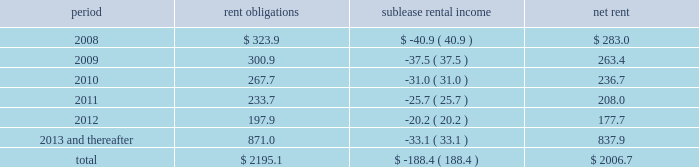Future minimum lease commitments for office premises and equipment under non-cancelable leases , along with minimum sublease rental income to be received under non-cancelable subleases , are as follows : period rent obligations sublease rental income net rent .
Guarantees we have certain contingent obligations under guarantees of certain of our subsidiaries ( 201cparent company guarantees 201d ) relating principally to credit facilities , guarantees of certain media payables and operating leases .
The amount of such parent company guarantees was $ 327.1 and $ 327.9 as of december 31 , 2007 and 2006 , respectively .
In the event of non-payment by the applicable subsidiary of the obligations covered by a guarantee , we would be obligated to pay the amounts covered by that guarantee .
As of december 31 , 2007 , there are no material assets pledged as security for such parent company guarantees .
Contingent acquisition obligations we have structured certain acquisitions with additional contingent purchase price obligations in order to reduce the potential risk associated with negative future performance of the acquired entity .
In addition , we have entered into agreements that may require us to purchase additional equity interests in certain consolidated and unconsolidated subsidiaries .
The amounts relating to these transactions are based on estimates of the future financial performance of the acquired entity , the timing of the exercise of these rights , changes in foreign currency exchange rates and other factors .
We have not recorded a liability for these items since the definitive amounts payable are not determinable or distributable .
When the contingent acquisition obligations have been met and consideration is determinable and distributable , we record the fair value of this consideration as an additional cost of the acquired entity .
However , we recognize deferred payments and purchases of additional interests after the effective date of purchase that are contingent upon the future employment of owners as compensation expense .
Compensation expense is determined based on the terms and conditions of the respective acquisition agreements and employment terms of the former owners of the acquired businesses .
This future expense will not be allocated to the assets and liabilities acquired and is amortized over the required employment terms of the former owners .
The following table details the estimated liability with respect to our contingent acquisition obligations and the estimated amount that would be paid under the options , in the event of exercise at the earliest exercise date .
All payments are contingent upon achieving projected operating performance targets and satisfying other notes to consolidated financial statements 2014 ( continued ) ( amounts in millions , except per share amounts ) .
What portion of total rent obligations will be paid-off through sublease rental income? 
Computations: (188.4 / 2195.1)
Answer: 0.08583. 